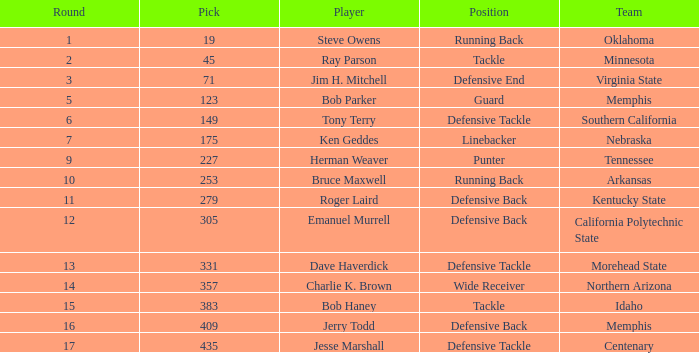What is the lowest pick of the defensive tackle player dave haverdick? 331.0. 